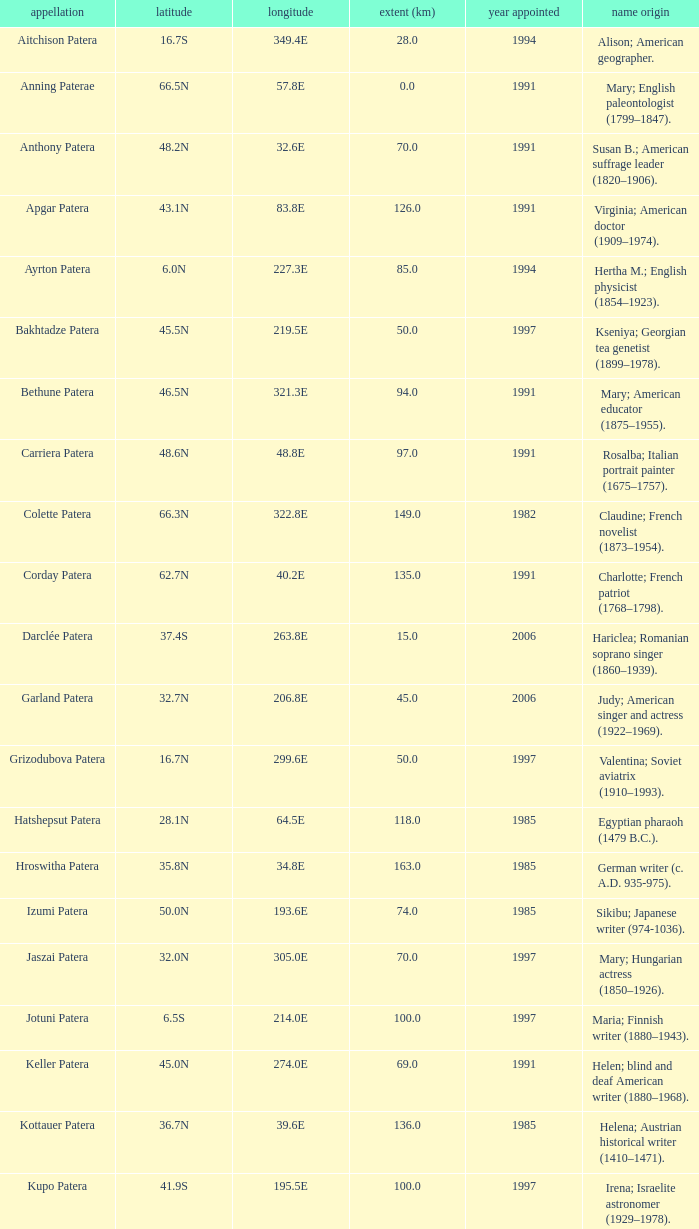What is the origin of the name of Keller Patera?  Helen; blind and deaf American writer (1880–1968). 